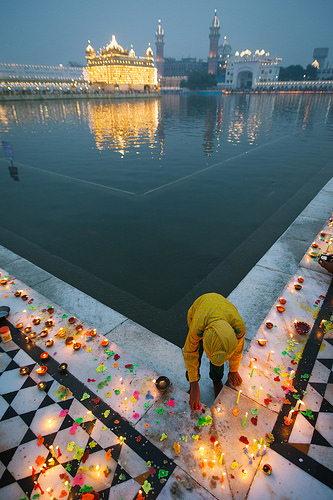<image>
Is there a candle behind the man? No. The candle is not behind the man. From this viewpoint, the candle appears to be positioned elsewhere in the scene. 